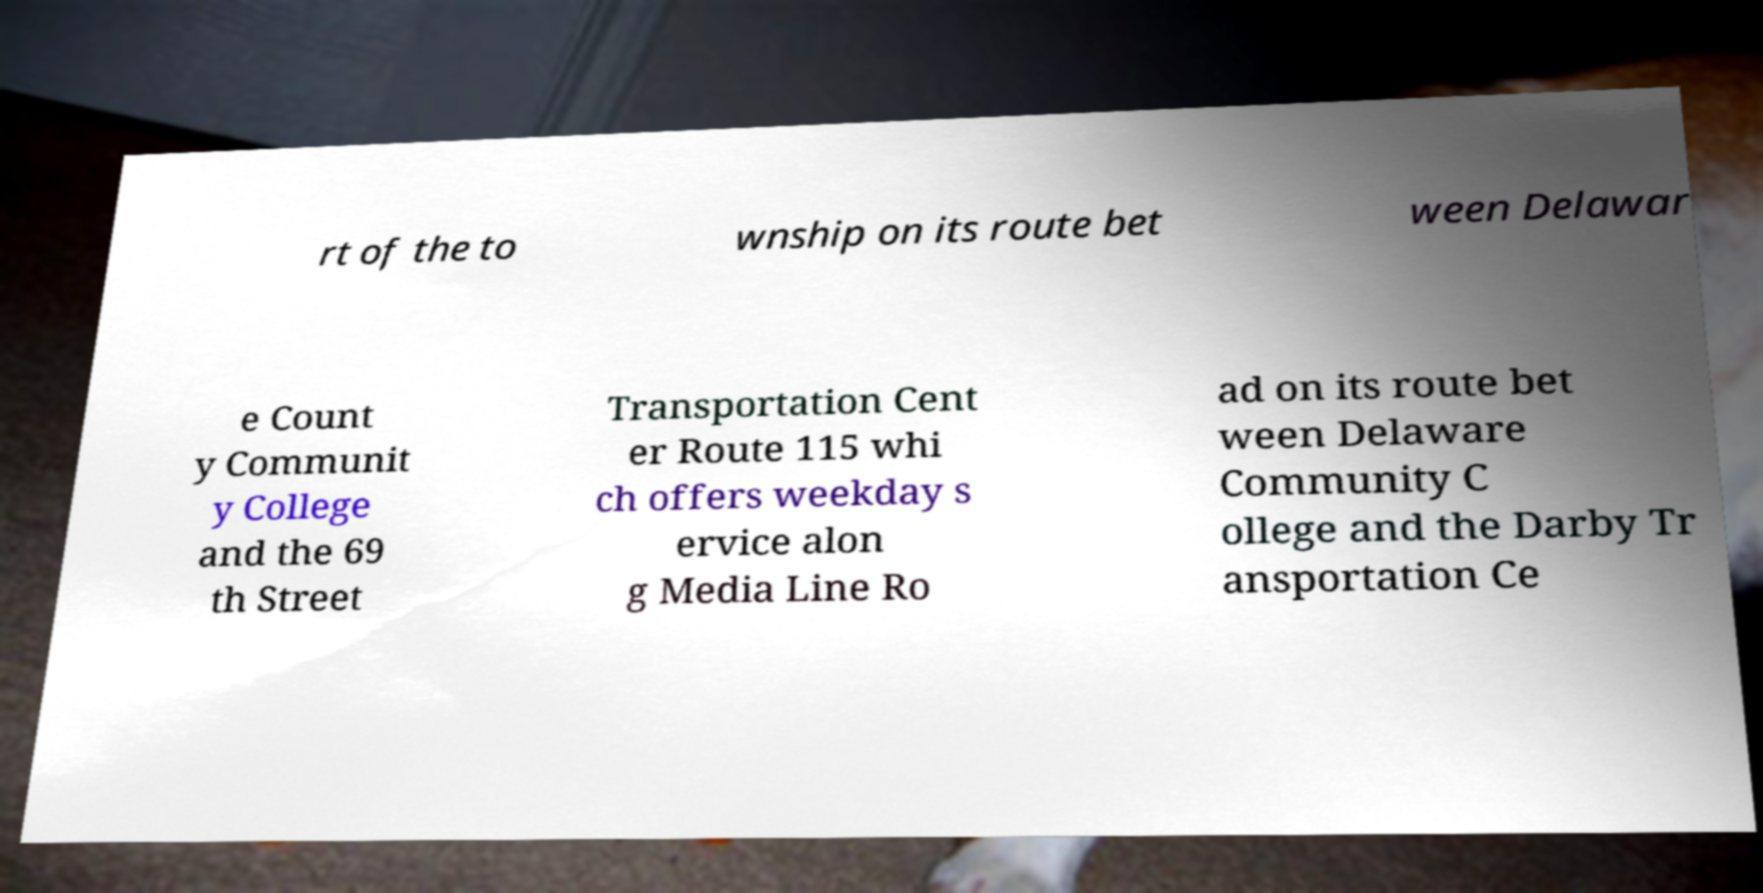There's text embedded in this image that I need extracted. Can you transcribe it verbatim? rt of the to wnship on its route bet ween Delawar e Count y Communit y College and the 69 th Street Transportation Cent er Route 115 whi ch offers weekday s ervice alon g Media Line Ro ad on its route bet ween Delaware Community C ollege and the Darby Tr ansportation Ce 